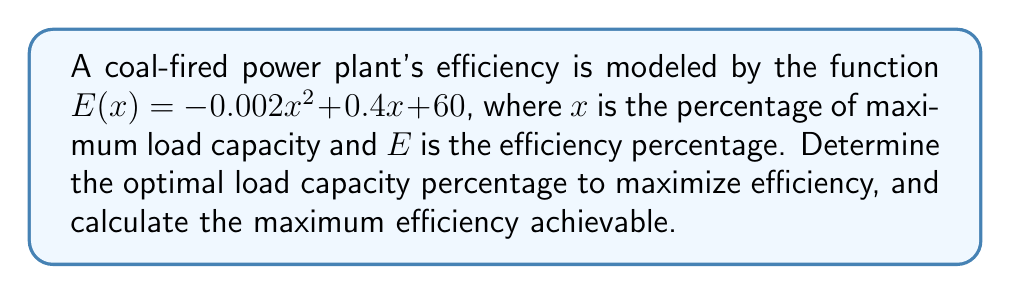Provide a solution to this math problem. To solve this optimization problem, we'll follow these steps:

1) The efficiency function is a quadratic equation in the form $E(x) = ax^2 + bx + c$, where:
   $a = -0.002$
   $b = 0.4$
   $c = 60$

2) To find the maximum point of a quadratic function, we need to find the vertex. The x-coordinate of the vertex represents the optimal load capacity percentage, and the y-coordinate represents the maximum efficiency.

3) For a quadratic function $f(x) = ax^2 + bx + c$, the x-coordinate of the vertex is given by $x = -\frac{b}{2a}$

4) Let's calculate the optimal load capacity percentage:

   $x = -\frac{b}{2a} = -\frac{0.4}{2(-0.002)} = \frac{0.4}{0.004} = 100$

5) To find the maximum efficiency, we substitute this x-value back into the original function:

   $E(100) = -0.002(100)^2 + 0.4(100) + 60$
           $= -20 + 40 + 60$
           $= 80$

Therefore, the optimal load capacity percentage is 100%, and the maximum efficiency achievable is 80%.
Answer: Optimal load capacity: 100%
Maximum efficiency: 80% 